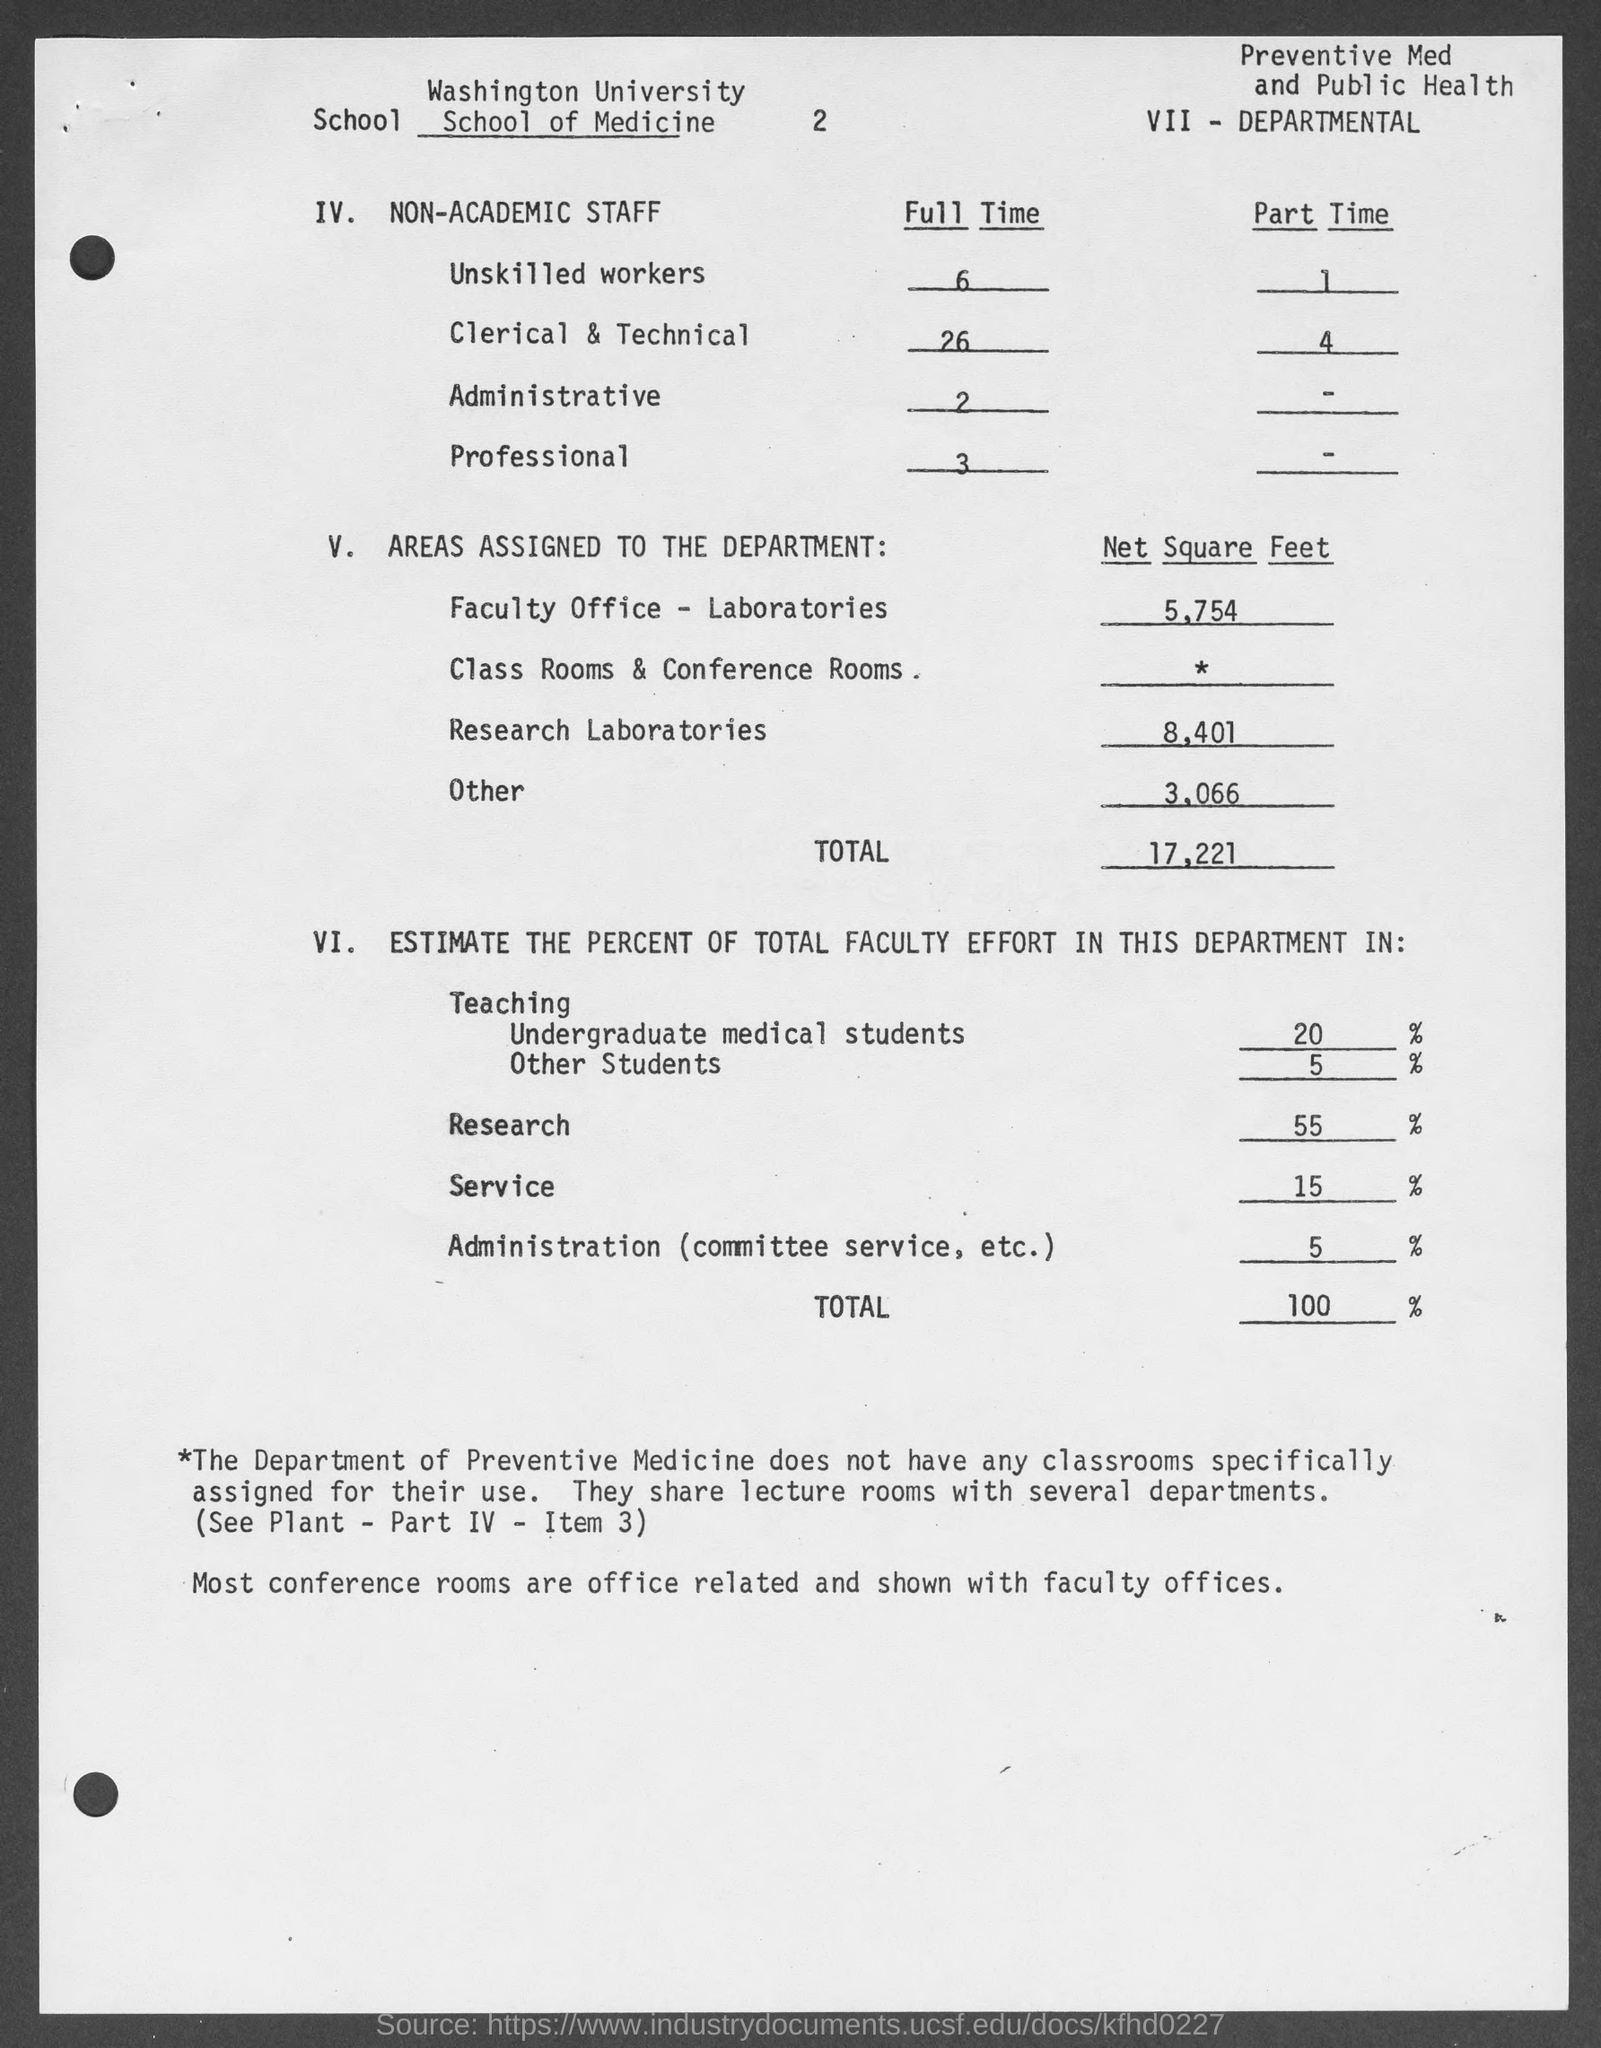How many clerical & technical staffs are assigned full time work?
Your response must be concise. 26. What is the no of unskilled workers doing part time work?
Your answer should be very brief. 1. What is the no of administrative staffs doing full time work?
Your response must be concise. 2. What is the area (in Net Square Feet)  assigned to Faculty office - Laboratories?
Your answer should be very brief. 5,754. What is the area (in Net Square Feet)  assigned to Research Laboratories?
Your answer should be very brief. 8,401. What is the total area (in Net Square Feet)  assigned to the department?
Offer a terse response. 17,221. What is the estimated percent of total faculty effort in the research department?
Your answer should be compact. 55 %. What is the estimate percent of total faculty effort in the Administration department?
Make the answer very short. 5%. 